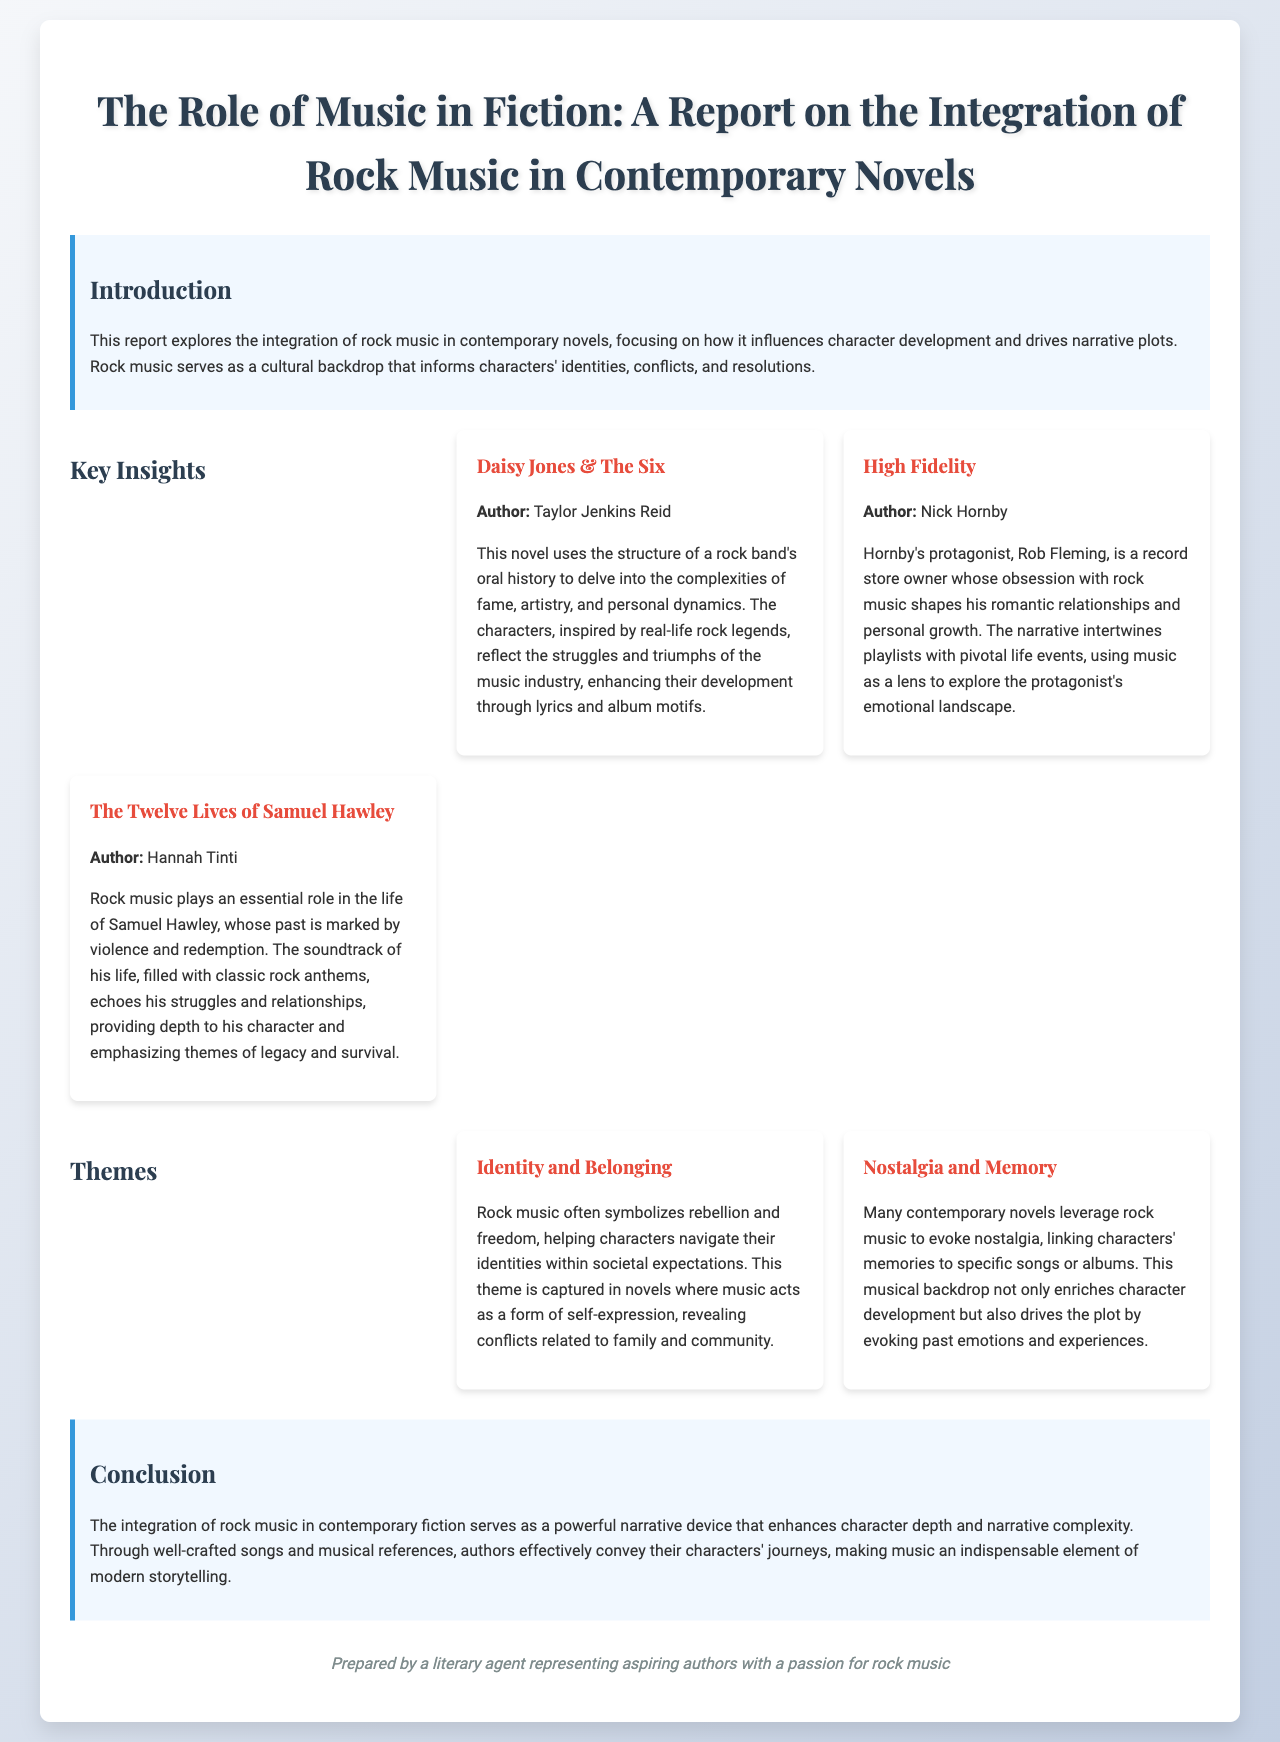What is the title of the report? The title is explicitly mentioned at the beginning of the document.
Answer: The Role of Music in Fiction: A Report on the Integration of Rock Music in Contemporary Novels Who is the author of "Daisy Jones & The Six"? The report lists the author in the key insights section.
Answer: Taylor Jenkins Reid What theme is related to self-expression in the document? The theme presents concepts associated with characters' identities and music.
Answer: Identity and Belonging Which novel features a protagonist named Rob Fleming? This information can be found in the insights section of the report.
Answer: High Fidelity How many novels are discussed in the key insights section? The total is the sum of the novels listed in the insights section.
Answer: Three What type of music is integrated into contemporary fiction according to the report? The report specifies the genre of music that influences the novels discussed.
Answer: Rock music What is one of the key elements that music provides to characters? The report mentions a specific aspect that music influences in characters' lives.
Answer: Depth What does the conclusion state about rock music's role in modern storytelling? This information is summarized in the conclusion section of the report.
Answer: A powerful narrative device Which author wrote "The Twelve Lives of Samuel Hawley"? The report identifies the author linked to the novel mentioned.
Answer: Hannah Tinti 